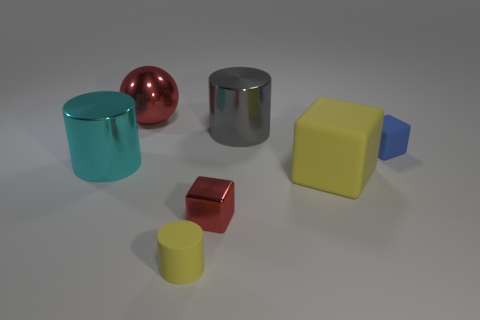Add 2 tiny metallic things. How many objects exist? 9 Subtract all blocks. How many objects are left? 4 Add 4 big yellow rubber things. How many big yellow rubber things exist? 5 Subtract 0 green cubes. How many objects are left? 7 Subtract all rubber objects. Subtract all small red cubes. How many objects are left? 3 Add 7 yellow cubes. How many yellow cubes are left? 8 